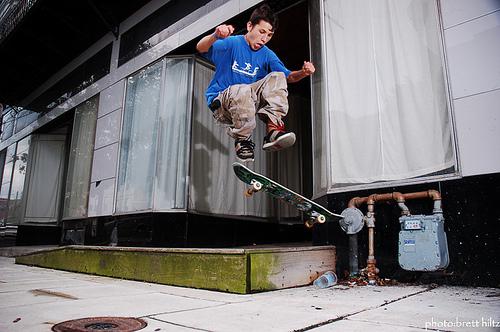Is his mouth open?
Answer briefly. Yes. Is this person alone?
Concise answer only. Yes. What is on his shirt?
Answer briefly. Skateboarder. 